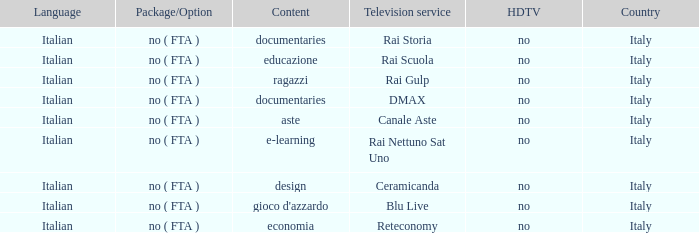What is the Language when the Reteconomy is the television service? Italian. 